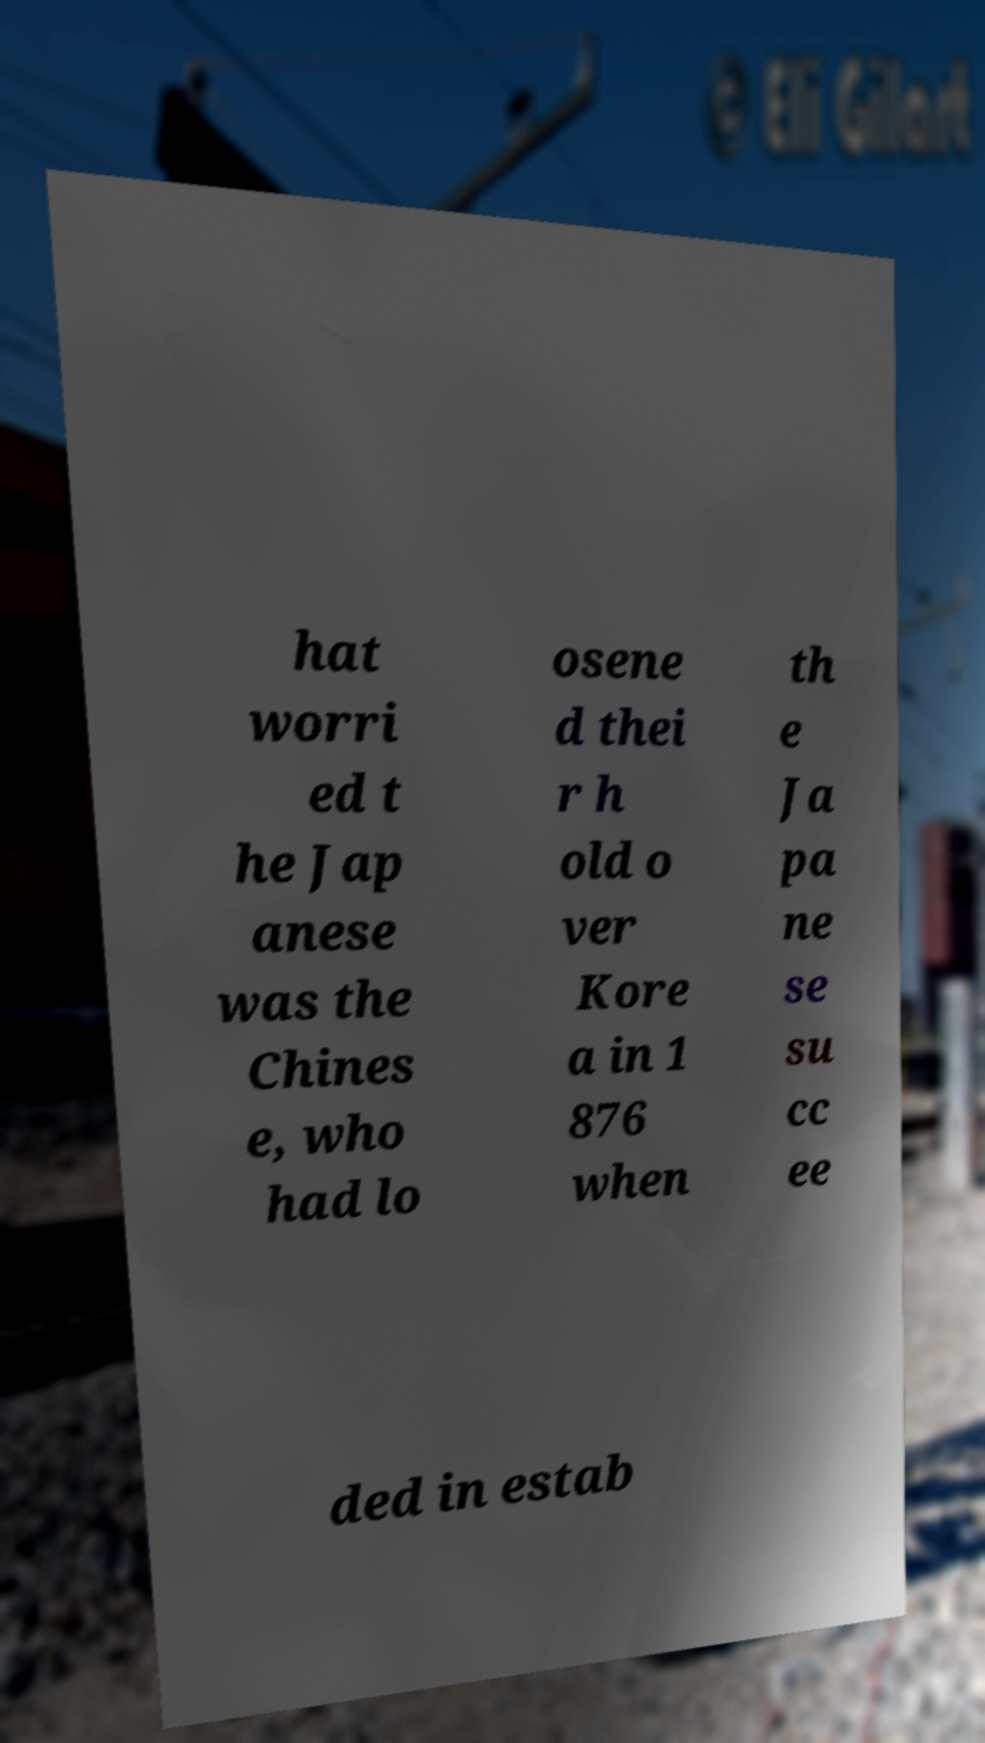Can you accurately transcribe the text from the provided image for me? hat worri ed t he Jap anese was the Chines e, who had lo osene d thei r h old o ver Kore a in 1 876 when th e Ja pa ne se su cc ee ded in estab 